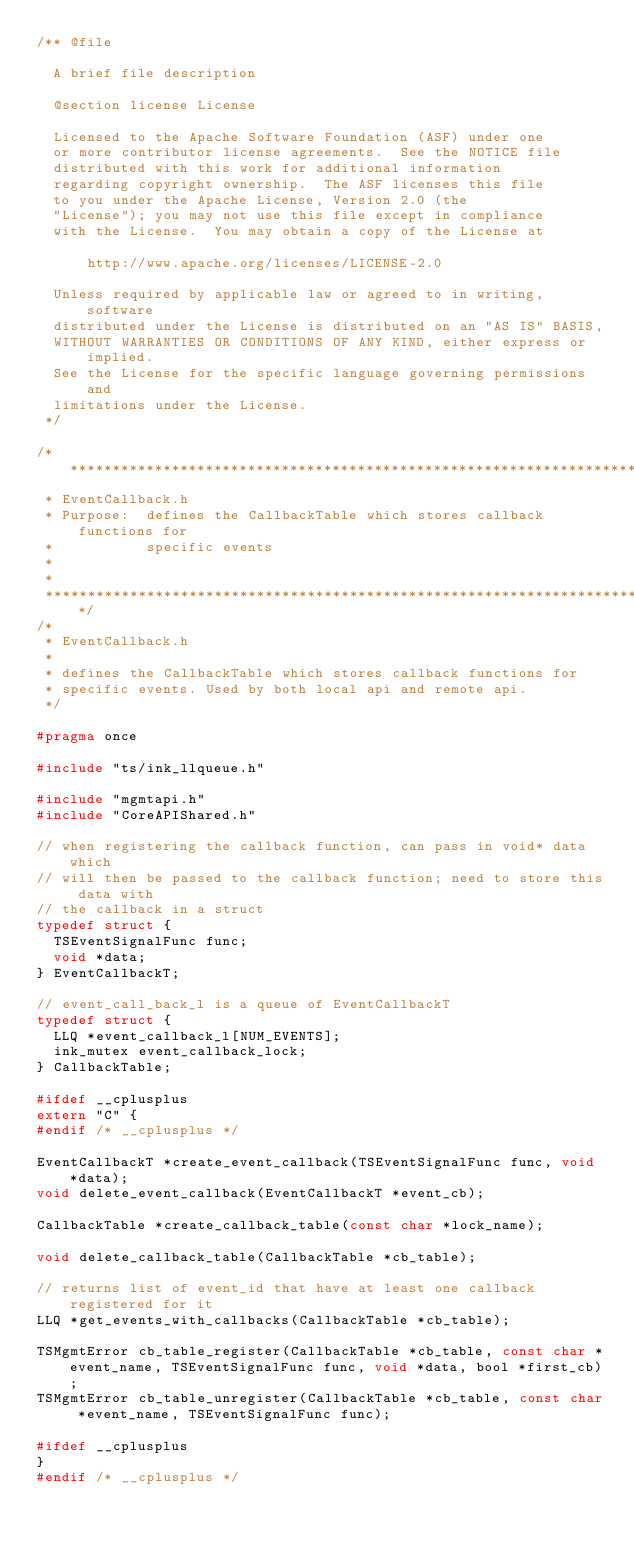<code> <loc_0><loc_0><loc_500><loc_500><_C_>/** @file

  A brief file description

  @section license License

  Licensed to the Apache Software Foundation (ASF) under one
  or more contributor license agreements.  See the NOTICE file
  distributed with this work for additional information
  regarding copyright ownership.  The ASF licenses this file
  to you under the Apache License, Version 2.0 (the
  "License"); you may not use this file except in compliance
  with the License.  You may obtain a copy of the License at

      http://www.apache.org/licenses/LICENSE-2.0

  Unless required by applicable law or agreed to in writing, software
  distributed under the License is distributed on an "AS IS" BASIS,
  WITHOUT WARRANTIES OR CONDITIONS OF ANY KIND, either express or implied.
  See the License for the specific language governing permissions and
  limitations under the License.
 */

/***************************************************************************
 * EventCallback.h
 * Purpose:  defines the CallbackTable which stores callback functions for
 *           specific events
 *
 *
 ***************************************************************************/
/*
 * EventCallback.h
 *
 * defines the CallbackTable which stores callback functions for
 * specific events. Used by both local api and remote api.
 */

#pragma once

#include "ts/ink_llqueue.h"

#include "mgmtapi.h"
#include "CoreAPIShared.h"

// when registering the callback function, can pass in void* data which
// will then be passed to the callback function; need to store this data with
// the callback in a struct
typedef struct {
  TSEventSignalFunc func;
  void *data;
} EventCallbackT;

// event_call_back_l is a queue of EventCallbackT
typedef struct {
  LLQ *event_callback_l[NUM_EVENTS];
  ink_mutex event_callback_lock;
} CallbackTable;

#ifdef __cplusplus
extern "C" {
#endif /* __cplusplus */

EventCallbackT *create_event_callback(TSEventSignalFunc func, void *data);
void delete_event_callback(EventCallbackT *event_cb);

CallbackTable *create_callback_table(const char *lock_name);

void delete_callback_table(CallbackTable *cb_table);

// returns list of event_id that have at least one callback registered for it
LLQ *get_events_with_callbacks(CallbackTable *cb_table);

TSMgmtError cb_table_register(CallbackTable *cb_table, const char *event_name, TSEventSignalFunc func, void *data, bool *first_cb);
TSMgmtError cb_table_unregister(CallbackTable *cb_table, const char *event_name, TSEventSignalFunc func);

#ifdef __cplusplus
}
#endif /* __cplusplus */
</code> 